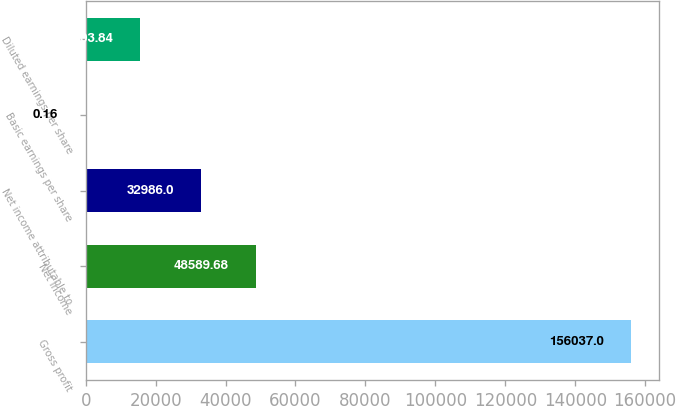<chart> <loc_0><loc_0><loc_500><loc_500><bar_chart><fcel>Gross profit<fcel>Net income<fcel>Net income attributable to<fcel>Basic earnings per share<fcel>Diluted earnings per share<nl><fcel>156037<fcel>48589.7<fcel>32986<fcel>0.16<fcel>15603.8<nl></chart> 